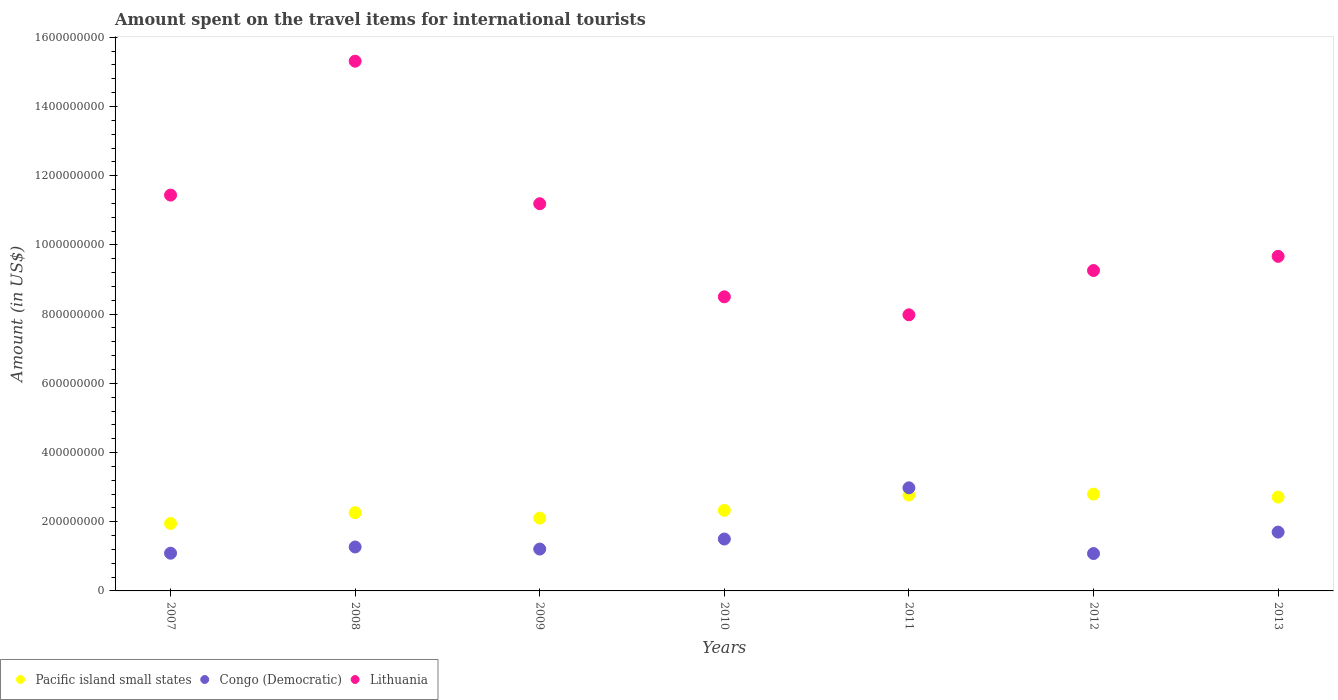Is the number of dotlines equal to the number of legend labels?
Give a very brief answer. Yes. What is the amount spent on the travel items for international tourists in Pacific island small states in 2010?
Make the answer very short. 2.33e+08. Across all years, what is the maximum amount spent on the travel items for international tourists in Congo (Democratic)?
Offer a very short reply. 2.98e+08. Across all years, what is the minimum amount spent on the travel items for international tourists in Congo (Democratic)?
Your answer should be very brief. 1.08e+08. In which year was the amount spent on the travel items for international tourists in Lithuania maximum?
Your response must be concise. 2008. What is the total amount spent on the travel items for international tourists in Congo (Democratic) in the graph?
Provide a short and direct response. 1.08e+09. What is the difference between the amount spent on the travel items for international tourists in Pacific island small states in 2008 and that in 2011?
Keep it short and to the point. -5.11e+07. What is the difference between the amount spent on the travel items for international tourists in Pacific island small states in 2009 and the amount spent on the travel items for international tourists in Lithuania in 2012?
Offer a very short reply. -7.16e+08. What is the average amount spent on the travel items for international tourists in Congo (Democratic) per year?
Offer a terse response. 1.55e+08. In the year 2007, what is the difference between the amount spent on the travel items for international tourists in Lithuania and amount spent on the travel items for international tourists in Congo (Democratic)?
Your answer should be very brief. 1.04e+09. What is the ratio of the amount spent on the travel items for international tourists in Lithuania in 2010 to that in 2012?
Give a very brief answer. 0.92. Is the difference between the amount spent on the travel items for international tourists in Lithuania in 2008 and 2013 greater than the difference between the amount spent on the travel items for international tourists in Congo (Democratic) in 2008 and 2013?
Give a very brief answer. Yes. What is the difference between the highest and the second highest amount spent on the travel items for international tourists in Pacific island small states?
Give a very brief answer. 2.63e+06. What is the difference between the highest and the lowest amount spent on the travel items for international tourists in Lithuania?
Your answer should be very brief. 7.33e+08. In how many years, is the amount spent on the travel items for international tourists in Congo (Democratic) greater than the average amount spent on the travel items for international tourists in Congo (Democratic) taken over all years?
Ensure brevity in your answer.  2. Is it the case that in every year, the sum of the amount spent on the travel items for international tourists in Pacific island small states and amount spent on the travel items for international tourists in Lithuania  is greater than the amount spent on the travel items for international tourists in Congo (Democratic)?
Make the answer very short. Yes. Does the amount spent on the travel items for international tourists in Lithuania monotonically increase over the years?
Ensure brevity in your answer.  No. Is the amount spent on the travel items for international tourists in Lithuania strictly less than the amount spent on the travel items for international tourists in Congo (Democratic) over the years?
Keep it short and to the point. No. How many dotlines are there?
Ensure brevity in your answer.  3. Are the values on the major ticks of Y-axis written in scientific E-notation?
Give a very brief answer. No. How are the legend labels stacked?
Ensure brevity in your answer.  Horizontal. What is the title of the graph?
Your response must be concise. Amount spent on the travel items for international tourists. What is the label or title of the X-axis?
Your answer should be compact. Years. What is the Amount (in US$) in Pacific island small states in 2007?
Offer a very short reply. 1.95e+08. What is the Amount (in US$) in Congo (Democratic) in 2007?
Your response must be concise. 1.09e+08. What is the Amount (in US$) in Lithuania in 2007?
Offer a very short reply. 1.14e+09. What is the Amount (in US$) of Pacific island small states in 2008?
Offer a very short reply. 2.26e+08. What is the Amount (in US$) in Congo (Democratic) in 2008?
Your answer should be compact. 1.27e+08. What is the Amount (in US$) in Lithuania in 2008?
Your response must be concise. 1.53e+09. What is the Amount (in US$) of Pacific island small states in 2009?
Provide a short and direct response. 2.10e+08. What is the Amount (in US$) of Congo (Democratic) in 2009?
Your response must be concise. 1.21e+08. What is the Amount (in US$) in Lithuania in 2009?
Make the answer very short. 1.12e+09. What is the Amount (in US$) of Pacific island small states in 2010?
Your response must be concise. 2.33e+08. What is the Amount (in US$) in Congo (Democratic) in 2010?
Your response must be concise. 1.50e+08. What is the Amount (in US$) of Lithuania in 2010?
Keep it short and to the point. 8.50e+08. What is the Amount (in US$) in Pacific island small states in 2011?
Make the answer very short. 2.77e+08. What is the Amount (in US$) in Congo (Democratic) in 2011?
Provide a succinct answer. 2.98e+08. What is the Amount (in US$) of Lithuania in 2011?
Your response must be concise. 7.98e+08. What is the Amount (in US$) of Pacific island small states in 2012?
Your answer should be very brief. 2.80e+08. What is the Amount (in US$) in Congo (Democratic) in 2012?
Offer a very short reply. 1.08e+08. What is the Amount (in US$) in Lithuania in 2012?
Your answer should be compact. 9.26e+08. What is the Amount (in US$) in Pacific island small states in 2013?
Your response must be concise. 2.71e+08. What is the Amount (in US$) in Congo (Democratic) in 2013?
Ensure brevity in your answer.  1.70e+08. What is the Amount (in US$) in Lithuania in 2013?
Your answer should be very brief. 9.67e+08. Across all years, what is the maximum Amount (in US$) in Pacific island small states?
Offer a terse response. 2.80e+08. Across all years, what is the maximum Amount (in US$) of Congo (Democratic)?
Make the answer very short. 2.98e+08. Across all years, what is the maximum Amount (in US$) in Lithuania?
Your response must be concise. 1.53e+09. Across all years, what is the minimum Amount (in US$) in Pacific island small states?
Give a very brief answer. 1.95e+08. Across all years, what is the minimum Amount (in US$) of Congo (Democratic)?
Give a very brief answer. 1.08e+08. Across all years, what is the minimum Amount (in US$) of Lithuania?
Your answer should be very brief. 7.98e+08. What is the total Amount (in US$) in Pacific island small states in the graph?
Offer a terse response. 1.69e+09. What is the total Amount (in US$) in Congo (Democratic) in the graph?
Give a very brief answer. 1.08e+09. What is the total Amount (in US$) of Lithuania in the graph?
Give a very brief answer. 7.34e+09. What is the difference between the Amount (in US$) of Pacific island small states in 2007 and that in 2008?
Your response must be concise. -3.11e+07. What is the difference between the Amount (in US$) in Congo (Democratic) in 2007 and that in 2008?
Offer a terse response. -1.80e+07. What is the difference between the Amount (in US$) in Lithuania in 2007 and that in 2008?
Your response must be concise. -3.87e+08. What is the difference between the Amount (in US$) of Pacific island small states in 2007 and that in 2009?
Offer a terse response. -1.55e+07. What is the difference between the Amount (in US$) in Congo (Democratic) in 2007 and that in 2009?
Provide a short and direct response. -1.20e+07. What is the difference between the Amount (in US$) in Lithuania in 2007 and that in 2009?
Your answer should be compact. 2.50e+07. What is the difference between the Amount (in US$) in Pacific island small states in 2007 and that in 2010?
Your response must be concise. -3.79e+07. What is the difference between the Amount (in US$) of Congo (Democratic) in 2007 and that in 2010?
Give a very brief answer. -4.10e+07. What is the difference between the Amount (in US$) in Lithuania in 2007 and that in 2010?
Provide a succinct answer. 2.94e+08. What is the difference between the Amount (in US$) in Pacific island small states in 2007 and that in 2011?
Ensure brevity in your answer.  -8.23e+07. What is the difference between the Amount (in US$) of Congo (Democratic) in 2007 and that in 2011?
Give a very brief answer. -1.89e+08. What is the difference between the Amount (in US$) in Lithuania in 2007 and that in 2011?
Provide a short and direct response. 3.46e+08. What is the difference between the Amount (in US$) of Pacific island small states in 2007 and that in 2012?
Your answer should be very brief. -8.49e+07. What is the difference between the Amount (in US$) in Congo (Democratic) in 2007 and that in 2012?
Your answer should be compact. 1.00e+06. What is the difference between the Amount (in US$) in Lithuania in 2007 and that in 2012?
Your response must be concise. 2.18e+08. What is the difference between the Amount (in US$) of Pacific island small states in 2007 and that in 2013?
Give a very brief answer. -7.63e+07. What is the difference between the Amount (in US$) of Congo (Democratic) in 2007 and that in 2013?
Offer a terse response. -6.10e+07. What is the difference between the Amount (in US$) in Lithuania in 2007 and that in 2013?
Your response must be concise. 1.77e+08. What is the difference between the Amount (in US$) in Pacific island small states in 2008 and that in 2009?
Provide a short and direct response. 1.57e+07. What is the difference between the Amount (in US$) of Congo (Democratic) in 2008 and that in 2009?
Offer a very short reply. 6.00e+06. What is the difference between the Amount (in US$) in Lithuania in 2008 and that in 2009?
Provide a short and direct response. 4.12e+08. What is the difference between the Amount (in US$) in Pacific island small states in 2008 and that in 2010?
Provide a succinct answer. -6.73e+06. What is the difference between the Amount (in US$) of Congo (Democratic) in 2008 and that in 2010?
Your answer should be very brief. -2.30e+07. What is the difference between the Amount (in US$) of Lithuania in 2008 and that in 2010?
Provide a short and direct response. 6.81e+08. What is the difference between the Amount (in US$) in Pacific island small states in 2008 and that in 2011?
Keep it short and to the point. -5.11e+07. What is the difference between the Amount (in US$) in Congo (Democratic) in 2008 and that in 2011?
Offer a very short reply. -1.71e+08. What is the difference between the Amount (in US$) of Lithuania in 2008 and that in 2011?
Your response must be concise. 7.33e+08. What is the difference between the Amount (in US$) in Pacific island small states in 2008 and that in 2012?
Your response must be concise. -5.38e+07. What is the difference between the Amount (in US$) of Congo (Democratic) in 2008 and that in 2012?
Your answer should be compact. 1.90e+07. What is the difference between the Amount (in US$) in Lithuania in 2008 and that in 2012?
Offer a very short reply. 6.05e+08. What is the difference between the Amount (in US$) in Pacific island small states in 2008 and that in 2013?
Your answer should be compact. -4.52e+07. What is the difference between the Amount (in US$) in Congo (Democratic) in 2008 and that in 2013?
Provide a short and direct response. -4.30e+07. What is the difference between the Amount (in US$) of Lithuania in 2008 and that in 2013?
Provide a short and direct response. 5.64e+08. What is the difference between the Amount (in US$) of Pacific island small states in 2009 and that in 2010?
Your answer should be compact. -2.24e+07. What is the difference between the Amount (in US$) in Congo (Democratic) in 2009 and that in 2010?
Give a very brief answer. -2.90e+07. What is the difference between the Amount (in US$) in Lithuania in 2009 and that in 2010?
Give a very brief answer. 2.69e+08. What is the difference between the Amount (in US$) in Pacific island small states in 2009 and that in 2011?
Make the answer very short. -6.68e+07. What is the difference between the Amount (in US$) in Congo (Democratic) in 2009 and that in 2011?
Your answer should be very brief. -1.77e+08. What is the difference between the Amount (in US$) in Lithuania in 2009 and that in 2011?
Provide a succinct answer. 3.21e+08. What is the difference between the Amount (in US$) in Pacific island small states in 2009 and that in 2012?
Give a very brief answer. -6.94e+07. What is the difference between the Amount (in US$) in Congo (Democratic) in 2009 and that in 2012?
Provide a succinct answer. 1.30e+07. What is the difference between the Amount (in US$) in Lithuania in 2009 and that in 2012?
Keep it short and to the point. 1.93e+08. What is the difference between the Amount (in US$) of Pacific island small states in 2009 and that in 2013?
Keep it short and to the point. -6.08e+07. What is the difference between the Amount (in US$) in Congo (Democratic) in 2009 and that in 2013?
Offer a very short reply. -4.90e+07. What is the difference between the Amount (in US$) in Lithuania in 2009 and that in 2013?
Ensure brevity in your answer.  1.52e+08. What is the difference between the Amount (in US$) of Pacific island small states in 2010 and that in 2011?
Your answer should be compact. -4.44e+07. What is the difference between the Amount (in US$) of Congo (Democratic) in 2010 and that in 2011?
Provide a succinct answer. -1.48e+08. What is the difference between the Amount (in US$) of Lithuania in 2010 and that in 2011?
Your response must be concise. 5.20e+07. What is the difference between the Amount (in US$) of Pacific island small states in 2010 and that in 2012?
Provide a succinct answer. -4.70e+07. What is the difference between the Amount (in US$) in Congo (Democratic) in 2010 and that in 2012?
Your response must be concise. 4.20e+07. What is the difference between the Amount (in US$) of Lithuania in 2010 and that in 2012?
Keep it short and to the point. -7.60e+07. What is the difference between the Amount (in US$) in Pacific island small states in 2010 and that in 2013?
Provide a short and direct response. -3.84e+07. What is the difference between the Amount (in US$) in Congo (Democratic) in 2010 and that in 2013?
Provide a succinct answer. -2.00e+07. What is the difference between the Amount (in US$) in Lithuania in 2010 and that in 2013?
Provide a succinct answer. -1.17e+08. What is the difference between the Amount (in US$) of Pacific island small states in 2011 and that in 2012?
Your response must be concise. -2.63e+06. What is the difference between the Amount (in US$) in Congo (Democratic) in 2011 and that in 2012?
Give a very brief answer. 1.90e+08. What is the difference between the Amount (in US$) in Lithuania in 2011 and that in 2012?
Your answer should be compact. -1.28e+08. What is the difference between the Amount (in US$) in Pacific island small states in 2011 and that in 2013?
Your response must be concise. 5.95e+06. What is the difference between the Amount (in US$) in Congo (Democratic) in 2011 and that in 2013?
Keep it short and to the point. 1.28e+08. What is the difference between the Amount (in US$) in Lithuania in 2011 and that in 2013?
Make the answer very short. -1.69e+08. What is the difference between the Amount (in US$) of Pacific island small states in 2012 and that in 2013?
Give a very brief answer. 8.58e+06. What is the difference between the Amount (in US$) of Congo (Democratic) in 2012 and that in 2013?
Provide a succinct answer. -6.20e+07. What is the difference between the Amount (in US$) in Lithuania in 2012 and that in 2013?
Make the answer very short. -4.10e+07. What is the difference between the Amount (in US$) in Pacific island small states in 2007 and the Amount (in US$) in Congo (Democratic) in 2008?
Offer a terse response. 6.79e+07. What is the difference between the Amount (in US$) in Pacific island small states in 2007 and the Amount (in US$) in Lithuania in 2008?
Provide a short and direct response. -1.34e+09. What is the difference between the Amount (in US$) in Congo (Democratic) in 2007 and the Amount (in US$) in Lithuania in 2008?
Your answer should be compact. -1.42e+09. What is the difference between the Amount (in US$) of Pacific island small states in 2007 and the Amount (in US$) of Congo (Democratic) in 2009?
Your answer should be very brief. 7.39e+07. What is the difference between the Amount (in US$) in Pacific island small states in 2007 and the Amount (in US$) in Lithuania in 2009?
Offer a terse response. -9.24e+08. What is the difference between the Amount (in US$) of Congo (Democratic) in 2007 and the Amount (in US$) of Lithuania in 2009?
Offer a very short reply. -1.01e+09. What is the difference between the Amount (in US$) of Pacific island small states in 2007 and the Amount (in US$) of Congo (Democratic) in 2010?
Offer a very short reply. 4.49e+07. What is the difference between the Amount (in US$) of Pacific island small states in 2007 and the Amount (in US$) of Lithuania in 2010?
Give a very brief answer. -6.55e+08. What is the difference between the Amount (in US$) of Congo (Democratic) in 2007 and the Amount (in US$) of Lithuania in 2010?
Keep it short and to the point. -7.41e+08. What is the difference between the Amount (in US$) in Pacific island small states in 2007 and the Amount (in US$) in Congo (Democratic) in 2011?
Make the answer very short. -1.03e+08. What is the difference between the Amount (in US$) in Pacific island small states in 2007 and the Amount (in US$) in Lithuania in 2011?
Offer a terse response. -6.03e+08. What is the difference between the Amount (in US$) of Congo (Democratic) in 2007 and the Amount (in US$) of Lithuania in 2011?
Ensure brevity in your answer.  -6.89e+08. What is the difference between the Amount (in US$) of Pacific island small states in 2007 and the Amount (in US$) of Congo (Democratic) in 2012?
Your response must be concise. 8.69e+07. What is the difference between the Amount (in US$) in Pacific island small states in 2007 and the Amount (in US$) in Lithuania in 2012?
Provide a succinct answer. -7.31e+08. What is the difference between the Amount (in US$) in Congo (Democratic) in 2007 and the Amount (in US$) in Lithuania in 2012?
Keep it short and to the point. -8.17e+08. What is the difference between the Amount (in US$) in Pacific island small states in 2007 and the Amount (in US$) in Congo (Democratic) in 2013?
Give a very brief answer. 2.49e+07. What is the difference between the Amount (in US$) of Pacific island small states in 2007 and the Amount (in US$) of Lithuania in 2013?
Provide a succinct answer. -7.72e+08. What is the difference between the Amount (in US$) of Congo (Democratic) in 2007 and the Amount (in US$) of Lithuania in 2013?
Offer a terse response. -8.58e+08. What is the difference between the Amount (in US$) of Pacific island small states in 2008 and the Amount (in US$) of Congo (Democratic) in 2009?
Your answer should be very brief. 1.05e+08. What is the difference between the Amount (in US$) of Pacific island small states in 2008 and the Amount (in US$) of Lithuania in 2009?
Your answer should be compact. -8.93e+08. What is the difference between the Amount (in US$) in Congo (Democratic) in 2008 and the Amount (in US$) in Lithuania in 2009?
Offer a terse response. -9.92e+08. What is the difference between the Amount (in US$) of Pacific island small states in 2008 and the Amount (in US$) of Congo (Democratic) in 2010?
Offer a terse response. 7.61e+07. What is the difference between the Amount (in US$) of Pacific island small states in 2008 and the Amount (in US$) of Lithuania in 2010?
Offer a terse response. -6.24e+08. What is the difference between the Amount (in US$) of Congo (Democratic) in 2008 and the Amount (in US$) of Lithuania in 2010?
Keep it short and to the point. -7.23e+08. What is the difference between the Amount (in US$) of Pacific island small states in 2008 and the Amount (in US$) of Congo (Democratic) in 2011?
Ensure brevity in your answer.  -7.19e+07. What is the difference between the Amount (in US$) of Pacific island small states in 2008 and the Amount (in US$) of Lithuania in 2011?
Offer a very short reply. -5.72e+08. What is the difference between the Amount (in US$) of Congo (Democratic) in 2008 and the Amount (in US$) of Lithuania in 2011?
Provide a short and direct response. -6.71e+08. What is the difference between the Amount (in US$) of Pacific island small states in 2008 and the Amount (in US$) of Congo (Democratic) in 2012?
Give a very brief answer. 1.18e+08. What is the difference between the Amount (in US$) of Pacific island small states in 2008 and the Amount (in US$) of Lithuania in 2012?
Offer a terse response. -7.00e+08. What is the difference between the Amount (in US$) in Congo (Democratic) in 2008 and the Amount (in US$) in Lithuania in 2012?
Your response must be concise. -7.99e+08. What is the difference between the Amount (in US$) in Pacific island small states in 2008 and the Amount (in US$) in Congo (Democratic) in 2013?
Ensure brevity in your answer.  5.61e+07. What is the difference between the Amount (in US$) in Pacific island small states in 2008 and the Amount (in US$) in Lithuania in 2013?
Ensure brevity in your answer.  -7.41e+08. What is the difference between the Amount (in US$) of Congo (Democratic) in 2008 and the Amount (in US$) of Lithuania in 2013?
Provide a succinct answer. -8.40e+08. What is the difference between the Amount (in US$) of Pacific island small states in 2009 and the Amount (in US$) of Congo (Democratic) in 2010?
Provide a succinct answer. 6.04e+07. What is the difference between the Amount (in US$) of Pacific island small states in 2009 and the Amount (in US$) of Lithuania in 2010?
Your answer should be compact. -6.40e+08. What is the difference between the Amount (in US$) of Congo (Democratic) in 2009 and the Amount (in US$) of Lithuania in 2010?
Your answer should be very brief. -7.29e+08. What is the difference between the Amount (in US$) in Pacific island small states in 2009 and the Amount (in US$) in Congo (Democratic) in 2011?
Provide a short and direct response. -8.76e+07. What is the difference between the Amount (in US$) of Pacific island small states in 2009 and the Amount (in US$) of Lithuania in 2011?
Your answer should be compact. -5.88e+08. What is the difference between the Amount (in US$) in Congo (Democratic) in 2009 and the Amount (in US$) in Lithuania in 2011?
Ensure brevity in your answer.  -6.77e+08. What is the difference between the Amount (in US$) in Pacific island small states in 2009 and the Amount (in US$) in Congo (Democratic) in 2012?
Keep it short and to the point. 1.02e+08. What is the difference between the Amount (in US$) in Pacific island small states in 2009 and the Amount (in US$) in Lithuania in 2012?
Offer a very short reply. -7.16e+08. What is the difference between the Amount (in US$) of Congo (Democratic) in 2009 and the Amount (in US$) of Lithuania in 2012?
Offer a terse response. -8.05e+08. What is the difference between the Amount (in US$) of Pacific island small states in 2009 and the Amount (in US$) of Congo (Democratic) in 2013?
Offer a very short reply. 4.04e+07. What is the difference between the Amount (in US$) in Pacific island small states in 2009 and the Amount (in US$) in Lithuania in 2013?
Your response must be concise. -7.57e+08. What is the difference between the Amount (in US$) of Congo (Democratic) in 2009 and the Amount (in US$) of Lithuania in 2013?
Your answer should be compact. -8.46e+08. What is the difference between the Amount (in US$) of Pacific island small states in 2010 and the Amount (in US$) of Congo (Democratic) in 2011?
Provide a succinct answer. -6.52e+07. What is the difference between the Amount (in US$) in Pacific island small states in 2010 and the Amount (in US$) in Lithuania in 2011?
Ensure brevity in your answer.  -5.65e+08. What is the difference between the Amount (in US$) in Congo (Democratic) in 2010 and the Amount (in US$) in Lithuania in 2011?
Your response must be concise. -6.48e+08. What is the difference between the Amount (in US$) of Pacific island small states in 2010 and the Amount (in US$) of Congo (Democratic) in 2012?
Offer a very short reply. 1.25e+08. What is the difference between the Amount (in US$) of Pacific island small states in 2010 and the Amount (in US$) of Lithuania in 2012?
Offer a terse response. -6.93e+08. What is the difference between the Amount (in US$) in Congo (Democratic) in 2010 and the Amount (in US$) in Lithuania in 2012?
Keep it short and to the point. -7.76e+08. What is the difference between the Amount (in US$) in Pacific island small states in 2010 and the Amount (in US$) in Congo (Democratic) in 2013?
Offer a very short reply. 6.28e+07. What is the difference between the Amount (in US$) of Pacific island small states in 2010 and the Amount (in US$) of Lithuania in 2013?
Make the answer very short. -7.34e+08. What is the difference between the Amount (in US$) in Congo (Democratic) in 2010 and the Amount (in US$) in Lithuania in 2013?
Your answer should be very brief. -8.17e+08. What is the difference between the Amount (in US$) in Pacific island small states in 2011 and the Amount (in US$) in Congo (Democratic) in 2012?
Provide a succinct answer. 1.69e+08. What is the difference between the Amount (in US$) in Pacific island small states in 2011 and the Amount (in US$) in Lithuania in 2012?
Make the answer very short. -6.49e+08. What is the difference between the Amount (in US$) of Congo (Democratic) in 2011 and the Amount (in US$) of Lithuania in 2012?
Your response must be concise. -6.28e+08. What is the difference between the Amount (in US$) in Pacific island small states in 2011 and the Amount (in US$) in Congo (Democratic) in 2013?
Ensure brevity in your answer.  1.07e+08. What is the difference between the Amount (in US$) of Pacific island small states in 2011 and the Amount (in US$) of Lithuania in 2013?
Provide a succinct answer. -6.90e+08. What is the difference between the Amount (in US$) in Congo (Democratic) in 2011 and the Amount (in US$) in Lithuania in 2013?
Offer a very short reply. -6.69e+08. What is the difference between the Amount (in US$) of Pacific island small states in 2012 and the Amount (in US$) of Congo (Democratic) in 2013?
Your response must be concise. 1.10e+08. What is the difference between the Amount (in US$) of Pacific island small states in 2012 and the Amount (in US$) of Lithuania in 2013?
Provide a short and direct response. -6.87e+08. What is the difference between the Amount (in US$) of Congo (Democratic) in 2012 and the Amount (in US$) of Lithuania in 2013?
Provide a succinct answer. -8.59e+08. What is the average Amount (in US$) of Pacific island small states per year?
Your answer should be very brief. 2.42e+08. What is the average Amount (in US$) in Congo (Democratic) per year?
Provide a short and direct response. 1.55e+08. What is the average Amount (in US$) of Lithuania per year?
Your answer should be compact. 1.05e+09. In the year 2007, what is the difference between the Amount (in US$) of Pacific island small states and Amount (in US$) of Congo (Democratic)?
Your response must be concise. 8.59e+07. In the year 2007, what is the difference between the Amount (in US$) in Pacific island small states and Amount (in US$) in Lithuania?
Make the answer very short. -9.49e+08. In the year 2007, what is the difference between the Amount (in US$) of Congo (Democratic) and Amount (in US$) of Lithuania?
Your answer should be very brief. -1.04e+09. In the year 2008, what is the difference between the Amount (in US$) in Pacific island small states and Amount (in US$) in Congo (Democratic)?
Ensure brevity in your answer.  9.91e+07. In the year 2008, what is the difference between the Amount (in US$) in Pacific island small states and Amount (in US$) in Lithuania?
Give a very brief answer. -1.30e+09. In the year 2008, what is the difference between the Amount (in US$) of Congo (Democratic) and Amount (in US$) of Lithuania?
Keep it short and to the point. -1.40e+09. In the year 2009, what is the difference between the Amount (in US$) of Pacific island small states and Amount (in US$) of Congo (Democratic)?
Your answer should be very brief. 8.94e+07. In the year 2009, what is the difference between the Amount (in US$) of Pacific island small states and Amount (in US$) of Lithuania?
Ensure brevity in your answer.  -9.09e+08. In the year 2009, what is the difference between the Amount (in US$) of Congo (Democratic) and Amount (in US$) of Lithuania?
Your answer should be compact. -9.98e+08. In the year 2010, what is the difference between the Amount (in US$) in Pacific island small states and Amount (in US$) in Congo (Democratic)?
Make the answer very short. 8.28e+07. In the year 2010, what is the difference between the Amount (in US$) in Pacific island small states and Amount (in US$) in Lithuania?
Offer a very short reply. -6.17e+08. In the year 2010, what is the difference between the Amount (in US$) in Congo (Democratic) and Amount (in US$) in Lithuania?
Ensure brevity in your answer.  -7.00e+08. In the year 2011, what is the difference between the Amount (in US$) in Pacific island small states and Amount (in US$) in Congo (Democratic)?
Your response must be concise. -2.08e+07. In the year 2011, what is the difference between the Amount (in US$) in Pacific island small states and Amount (in US$) in Lithuania?
Give a very brief answer. -5.21e+08. In the year 2011, what is the difference between the Amount (in US$) of Congo (Democratic) and Amount (in US$) of Lithuania?
Offer a terse response. -5.00e+08. In the year 2012, what is the difference between the Amount (in US$) in Pacific island small states and Amount (in US$) in Congo (Democratic)?
Keep it short and to the point. 1.72e+08. In the year 2012, what is the difference between the Amount (in US$) in Pacific island small states and Amount (in US$) in Lithuania?
Your answer should be compact. -6.46e+08. In the year 2012, what is the difference between the Amount (in US$) in Congo (Democratic) and Amount (in US$) in Lithuania?
Offer a terse response. -8.18e+08. In the year 2013, what is the difference between the Amount (in US$) of Pacific island small states and Amount (in US$) of Congo (Democratic)?
Make the answer very short. 1.01e+08. In the year 2013, what is the difference between the Amount (in US$) of Pacific island small states and Amount (in US$) of Lithuania?
Offer a terse response. -6.96e+08. In the year 2013, what is the difference between the Amount (in US$) of Congo (Democratic) and Amount (in US$) of Lithuania?
Your answer should be very brief. -7.97e+08. What is the ratio of the Amount (in US$) of Pacific island small states in 2007 to that in 2008?
Provide a succinct answer. 0.86. What is the ratio of the Amount (in US$) in Congo (Democratic) in 2007 to that in 2008?
Give a very brief answer. 0.86. What is the ratio of the Amount (in US$) in Lithuania in 2007 to that in 2008?
Make the answer very short. 0.75. What is the ratio of the Amount (in US$) in Pacific island small states in 2007 to that in 2009?
Your response must be concise. 0.93. What is the ratio of the Amount (in US$) of Congo (Democratic) in 2007 to that in 2009?
Make the answer very short. 0.9. What is the ratio of the Amount (in US$) in Lithuania in 2007 to that in 2009?
Ensure brevity in your answer.  1.02. What is the ratio of the Amount (in US$) of Pacific island small states in 2007 to that in 2010?
Provide a short and direct response. 0.84. What is the ratio of the Amount (in US$) in Congo (Democratic) in 2007 to that in 2010?
Offer a terse response. 0.73. What is the ratio of the Amount (in US$) in Lithuania in 2007 to that in 2010?
Give a very brief answer. 1.35. What is the ratio of the Amount (in US$) in Pacific island small states in 2007 to that in 2011?
Offer a very short reply. 0.7. What is the ratio of the Amount (in US$) of Congo (Democratic) in 2007 to that in 2011?
Your answer should be very brief. 0.37. What is the ratio of the Amount (in US$) of Lithuania in 2007 to that in 2011?
Offer a terse response. 1.43. What is the ratio of the Amount (in US$) of Pacific island small states in 2007 to that in 2012?
Make the answer very short. 0.7. What is the ratio of the Amount (in US$) of Congo (Democratic) in 2007 to that in 2012?
Make the answer very short. 1.01. What is the ratio of the Amount (in US$) of Lithuania in 2007 to that in 2012?
Your response must be concise. 1.24. What is the ratio of the Amount (in US$) of Pacific island small states in 2007 to that in 2013?
Provide a succinct answer. 0.72. What is the ratio of the Amount (in US$) in Congo (Democratic) in 2007 to that in 2013?
Give a very brief answer. 0.64. What is the ratio of the Amount (in US$) of Lithuania in 2007 to that in 2013?
Provide a succinct answer. 1.18. What is the ratio of the Amount (in US$) of Pacific island small states in 2008 to that in 2009?
Offer a terse response. 1.07. What is the ratio of the Amount (in US$) of Congo (Democratic) in 2008 to that in 2009?
Your response must be concise. 1.05. What is the ratio of the Amount (in US$) of Lithuania in 2008 to that in 2009?
Ensure brevity in your answer.  1.37. What is the ratio of the Amount (in US$) of Pacific island small states in 2008 to that in 2010?
Offer a very short reply. 0.97. What is the ratio of the Amount (in US$) in Congo (Democratic) in 2008 to that in 2010?
Your response must be concise. 0.85. What is the ratio of the Amount (in US$) in Lithuania in 2008 to that in 2010?
Make the answer very short. 1.8. What is the ratio of the Amount (in US$) of Pacific island small states in 2008 to that in 2011?
Make the answer very short. 0.82. What is the ratio of the Amount (in US$) of Congo (Democratic) in 2008 to that in 2011?
Provide a succinct answer. 0.43. What is the ratio of the Amount (in US$) of Lithuania in 2008 to that in 2011?
Your answer should be compact. 1.92. What is the ratio of the Amount (in US$) in Pacific island small states in 2008 to that in 2012?
Your answer should be compact. 0.81. What is the ratio of the Amount (in US$) of Congo (Democratic) in 2008 to that in 2012?
Give a very brief answer. 1.18. What is the ratio of the Amount (in US$) of Lithuania in 2008 to that in 2012?
Provide a short and direct response. 1.65. What is the ratio of the Amount (in US$) of Pacific island small states in 2008 to that in 2013?
Offer a very short reply. 0.83. What is the ratio of the Amount (in US$) of Congo (Democratic) in 2008 to that in 2013?
Make the answer very short. 0.75. What is the ratio of the Amount (in US$) of Lithuania in 2008 to that in 2013?
Offer a very short reply. 1.58. What is the ratio of the Amount (in US$) in Pacific island small states in 2009 to that in 2010?
Provide a short and direct response. 0.9. What is the ratio of the Amount (in US$) of Congo (Democratic) in 2009 to that in 2010?
Ensure brevity in your answer.  0.81. What is the ratio of the Amount (in US$) of Lithuania in 2009 to that in 2010?
Your answer should be compact. 1.32. What is the ratio of the Amount (in US$) in Pacific island small states in 2009 to that in 2011?
Offer a terse response. 0.76. What is the ratio of the Amount (in US$) of Congo (Democratic) in 2009 to that in 2011?
Your answer should be compact. 0.41. What is the ratio of the Amount (in US$) in Lithuania in 2009 to that in 2011?
Your response must be concise. 1.4. What is the ratio of the Amount (in US$) in Pacific island small states in 2009 to that in 2012?
Keep it short and to the point. 0.75. What is the ratio of the Amount (in US$) of Congo (Democratic) in 2009 to that in 2012?
Provide a short and direct response. 1.12. What is the ratio of the Amount (in US$) of Lithuania in 2009 to that in 2012?
Offer a terse response. 1.21. What is the ratio of the Amount (in US$) of Pacific island small states in 2009 to that in 2013?
Keep it short and to the point. 0.78. What is the ratio of the Amount (in US$) of Congo (Democratic) in 2009 to that in 2013?
Your answer should be very brief. 0.71. What is the ratio of the Amount (in US$) of Lithuania in 2009 to that in 2013?
Give a very brief answer. 1.16. What is the ratio of the Amount (in US$) in Pacific island small states in 2010 to that in 2011?
Your answer should be very brief. 0.84. What is the ratio of the Amount (in US$) in Congo (Democratic) in 2010 to that in 2011?
Provide a short and direct response. 0.5. What is the ratio of the Amount (in US$) of Lithuania in 2010 to that in 2011?
Give a very brief answer. 1.07. What is the ratio of the Amount (in US$) in Pacific island small states in 2010 to that in 2012?
Your answer should be very brief. 0.83. What is the ratio of the Amount (in US$) of Congo (Democratic) in 2010 to that in 2012?
Offer a terse response. 1.39. What is the ratio of the Amount (in US$) of Lithuania in 2010 to that in 2012?
Ensure brevity in your answer.  0.92. What is the ratio of the Amount (in US$) in Pacific island small states in 2010 to that in 2013?
Your answer should be very brief. 0.86. What is the ratio of the Amount (in US$) in Congo (Democratic) in 2010 to that in 2013?
Provide a short and direct response. 0.88. What is the ratio of the Amount (in US$) of Lithuania in 2010 to that in 2013?
Provide a succinct answer. 0.88. What is the ratio of the Amount (in US$) in Pacific island small states in 2011 to that in 2012?
Offer a very short reply. 0.99. What is the ratio of the Amount (in US$) in Congo (Democratic) in 2011 to that in 2012?
Make the answer very short. 2.76. What is the ratio of the Amount (in US$) of Lithuania in 2011 to that in 2012?
Offer a terse response. 0.86. What is the ratio of the Amount (in US$) of Pacific island small states in 2011 to that in 2013?
Provide a short and direct response. 1.02. What is the ratio of the Amount (in US$) in Congo (Democratic) in 2011 to that in 2013?
Ensure brevity in your answer.  1.75. What is the ratio of the Amount (in US$) of Lithuania in 2011 to that in 2013?
Make the answer very short. 0.83. What is the ratio of the Amount (in US$) in Pacific island small states in 2012 to that in 2013?
Your answer should be compact. 1.03. What is the ratio of the Amount (in US$) in Congo (Democratic) in 2012 to that in 2013?
Offer a very short reply. 0.64. What is the ratio of the Amount (in US$) in Lithuania in 2012 to that in 2013?
Provide a short and direct response. 0.96. What is the difference between the highest and the second highest Amount (in US$) in Pacific island small states?
Your response must be concise. 2.63e+06. What is the difference between the highest and the second highest Amount (in US$) in Congo (Democratic)?
Offer a very short reply. 1.28e+08. What is the difference between the highest and the second highest Amount (in US$) of Lithuania?
Your answer should be very brief. 3.87e+08. What is the difference between the highest and the lowest Amount (in US$) of Pacific island small states?
Give a very brief answer. 8.49e+07. What is the difference between the highest and the lowest Amount (in US$) of Congo (Democratic)?
Make the answer very short. 1.90e+08. What is the difference between the highest and the lowest Amount (in US$) of Lithuania?
Provide a short and direct response. 7.33e+08. 